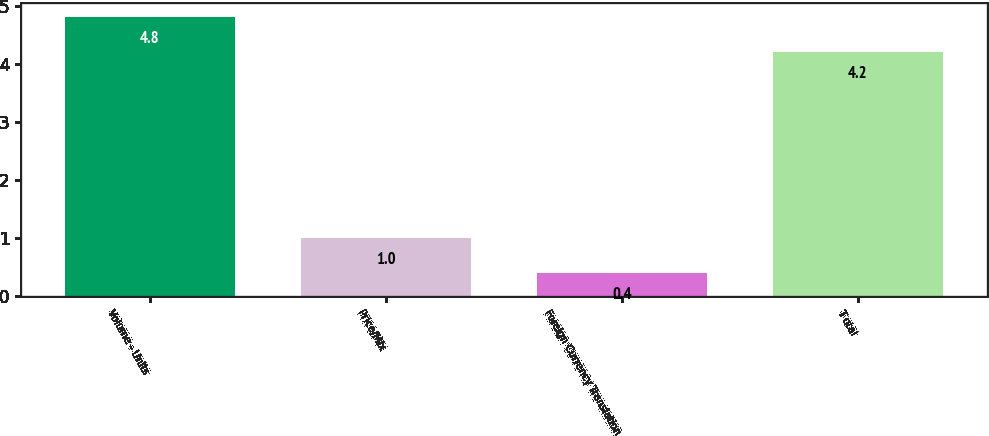Convert chart. <chart><loc_0><loc_0><loc_500><loc_500><bar_chart><fcel>Volume - Units<fcel>Price/Mix<fcel>Foreign Currency Translation<fcel>T otal<nl><fcel>4.8<fcel>1<fcel>0.4<fcel>4.2<nl></chart> 